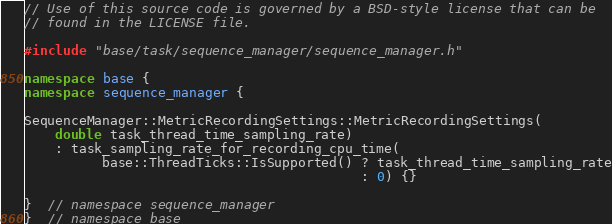Convert code to text. <code><loc_0><loc_0><loc_500><loc_500><_C++_>// Use of this source code is governed by a BSD-style license that can be
// found in the LICENSE file.

#include "base/task/sequence_manager/sequence_manager.h"

namespace base {
namespace sequence_manager {

SequenceManager::MetricRecordingSettings::MetricRecordingSettings(
    double task_thread_time_sampling_rate)
    : task_sampling_rate_for_recording_cpu_time(
          base::ThreadTicks::IsSupported() ? task_thread_time_sampling_rate
                                           : 0) {}

}  // namespace sequence_manager
}  // namespace base
</code> 